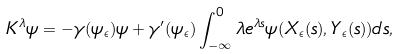Convert formula to latex. <formula><loc_0><loc_0><loc_500><loc_500>K ^ { \lambda } \psi = - \gamma ( \psi _ { \epsilon } ) \psi + \gamma ^ { \prime } ( \psi _ { \epsilon } ) \int _ { - \infty } ^ { 0 } \lambda e ^ { \lambda s } \psi ( X _ { \epsilon } ( s ) , Y _ { \epsilon } ( s ) ) d s ,</formula> 